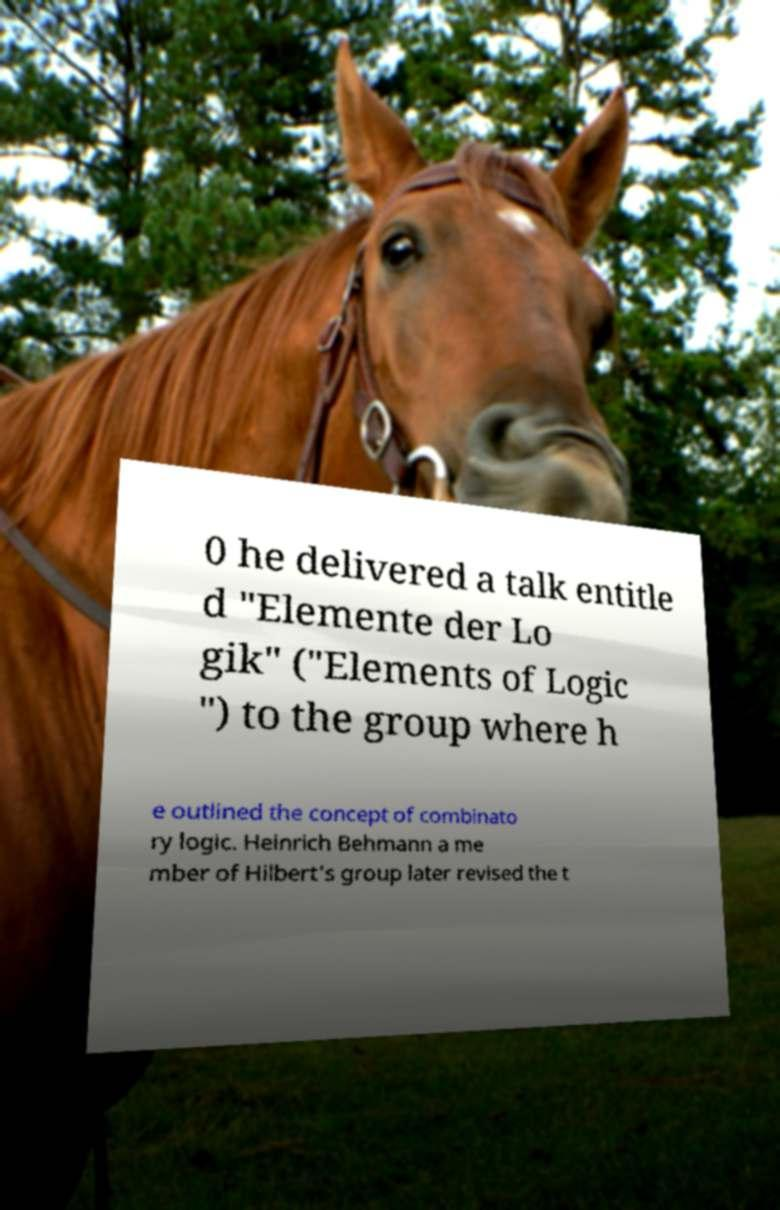Could you extract and type out the text from this image? 0 he delivered a talk entitle d "Elemente der Lo gik" ("Elements of Logic ") to the group where h e outlined the concept of combinato ry logic. Heinrich Behmann a me mber of Hilbert's group later revised the t 